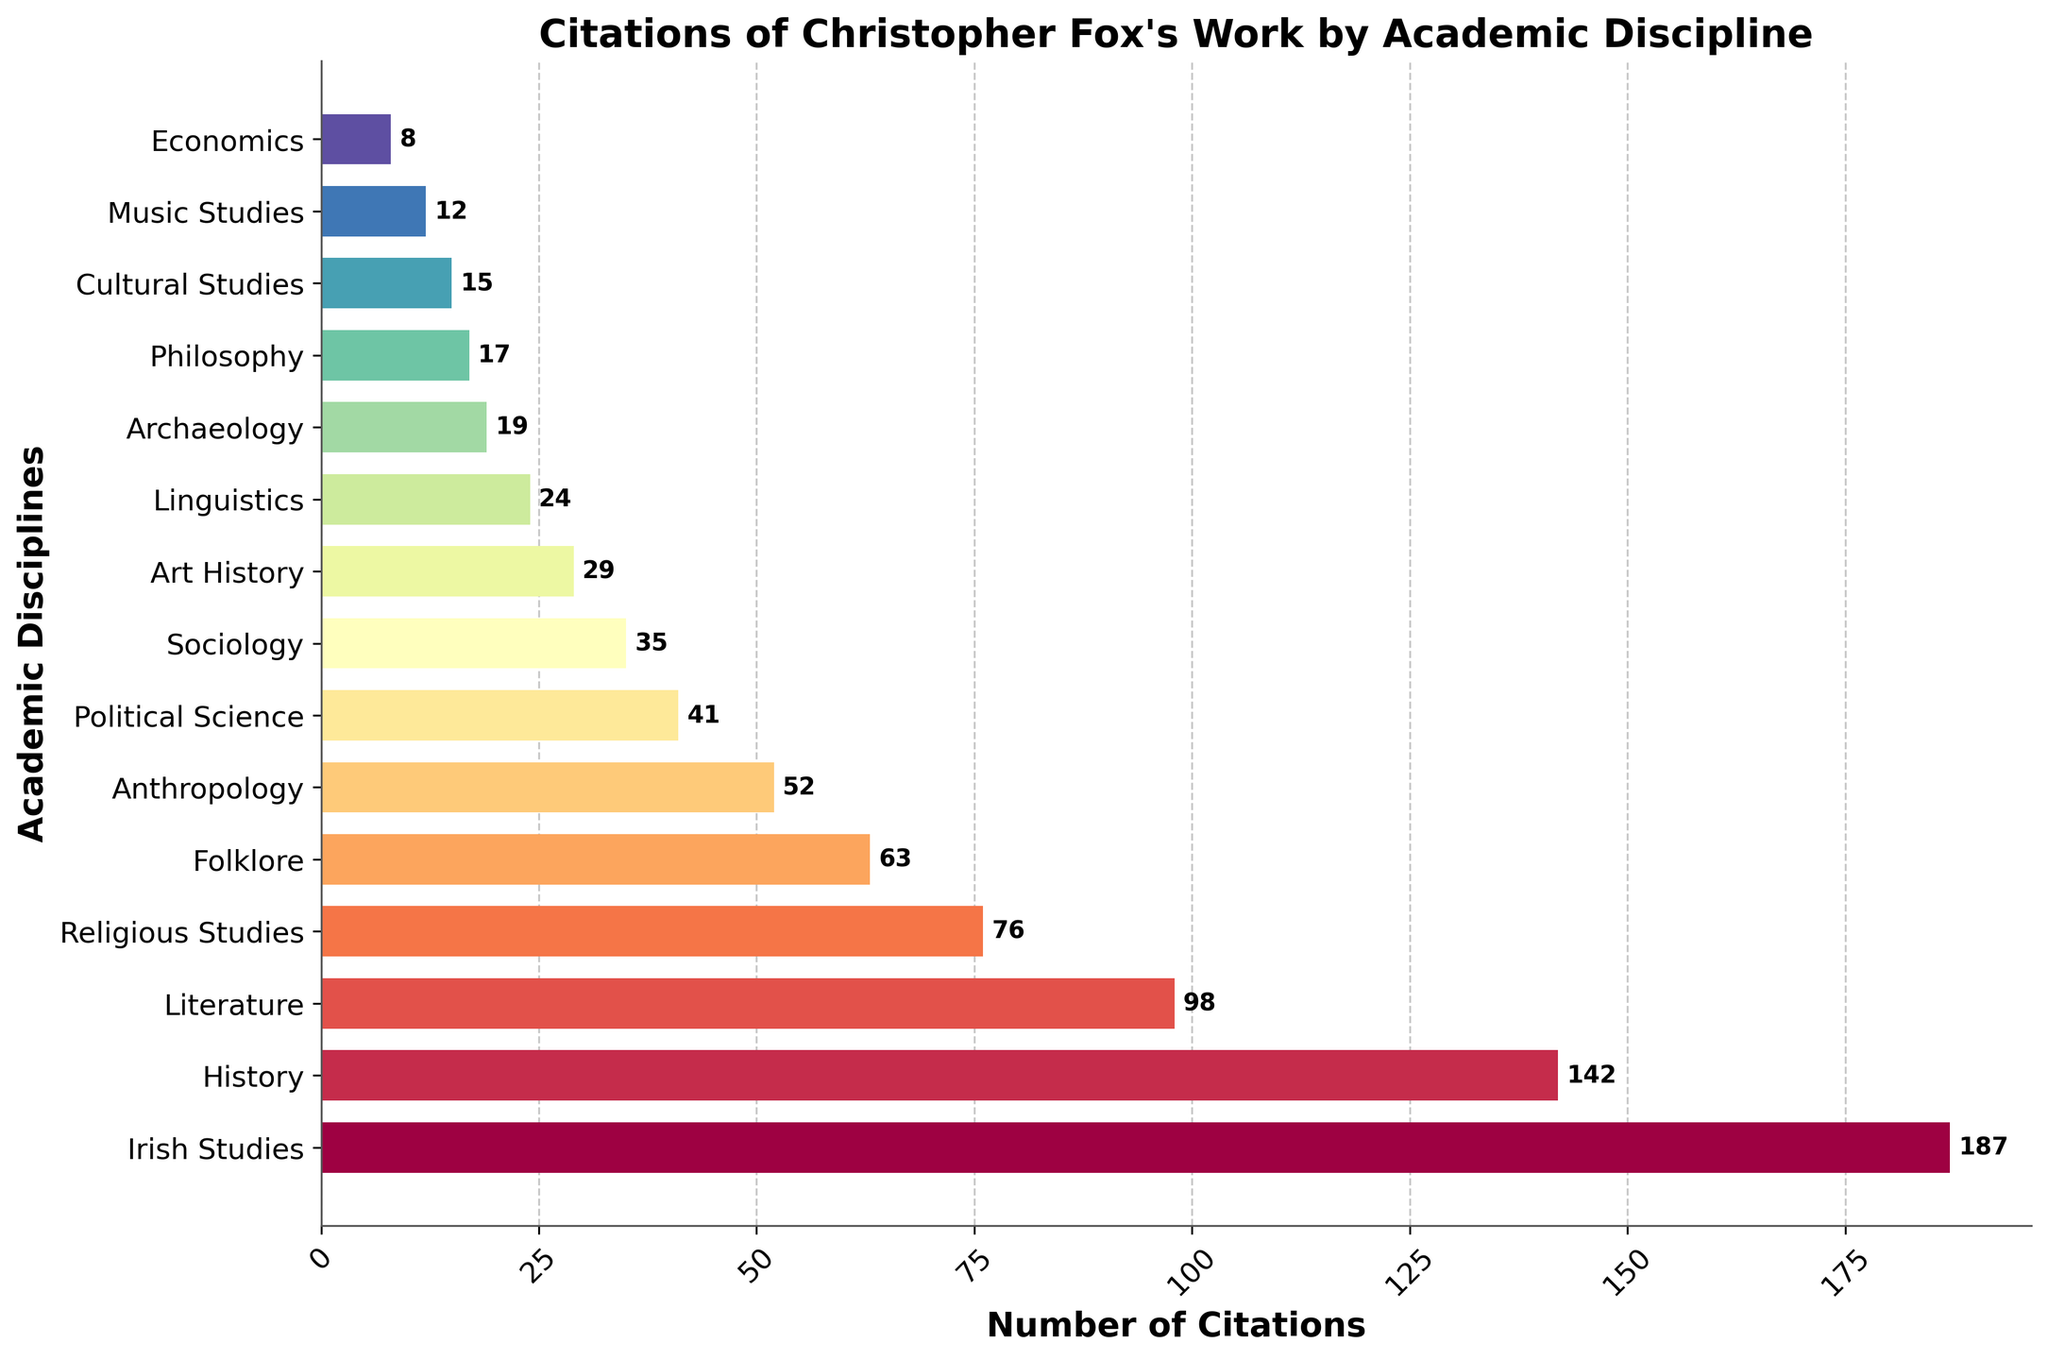What is the total number of citations across all disciplines? Sum the citations for all disciplines: 187 + 142 + 98 + 76 + 63 + 52 + 41 + 35 + 29 + 24 + 19 + 17 + 15 + 12 + 8 = 818
Answer: 818 Which academic discipline has the highest number of citations? Check the bar that reaches the farthest to the right. Irish Studies with 187 citations is the longest bar.
Answer: Irish Studies How many more citations does Irish Studies have compared to Political Science? Irish Studies has 187 citations and Political Science has 41 citations. Subtract 41 from 187: 187 - 41 = 146
Answer: 146 What is the average number of citations across all disciplines? Divide the total number of citations (818) by the number of disciplines (15). 818 / 15 ≈ 54.53
Answer: ≈ 54.53 Which disciplines have less than 20 citations each? Check the bars with lengths that correspond to values less than 20. Archaeology (19), Philosophy (17), Cultural Studies (15), Music Studies (12), and Economics (8).
Answer: Archaeology, Philosophy, Cultural Studies, Music Studies, Economics Is the number of citations in Literature greater than or less than the number of citations in Religious Studies? Compare the length of the bars for Literature and Religious Studies. Literature has 98 citations, Religious Studies has 76 citations. 98 is greater than 76.
Answer: Greater What is the difference in the number of citations between History and Art History? History has 142 citations, Art History has 29 citations. Subtract 29 from 142: 142 - 29 = 113
Answer: 113 Rank the top three disciplines by the number of citations. Order the disciplines by the height of their bars: Irish Studies (187), History (142), Literature (98).
Answer: 1. Irish Studies, 2. History, 3. Literature What is the combined number of citations for the social sciences disciplines (Anthropology, Sociology, Political Science, Economics)? Sum the citations for these disciplines: 52 (Anthropology) + 35 (Sociology) + 41 (Political Science) + 8 (Economics) = 136
Answer: 136 Which disciplines are cited more: Folklore or Anthropology? Compare the bars for Folklore and Anthropology. Folklore has 63 citations and Anthropology has 52 citations. 63 is greater than 52.
Answer: Folklore 